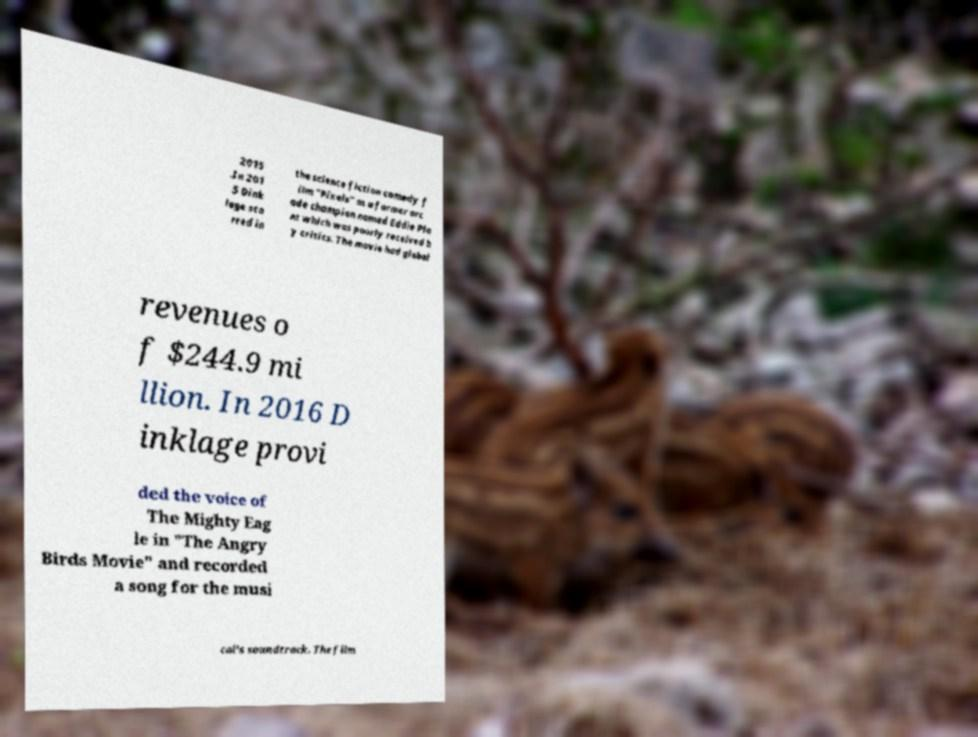Please identify and transcribe the text found in this image. 2015 .In 201 5 Dink lage sta rred in the science fiction comedy f ilm "Pixels" as a former arc ade champion named Eddie Pla nt which was poorly received b y critics. The movie had global revenues o f $244.9 mi llion. In 2016 D inklage provi ded the voice of The Mighty Eag le in "The Angry Birds Movie" and recorded a song for the musi cal's soundtrack. The film 